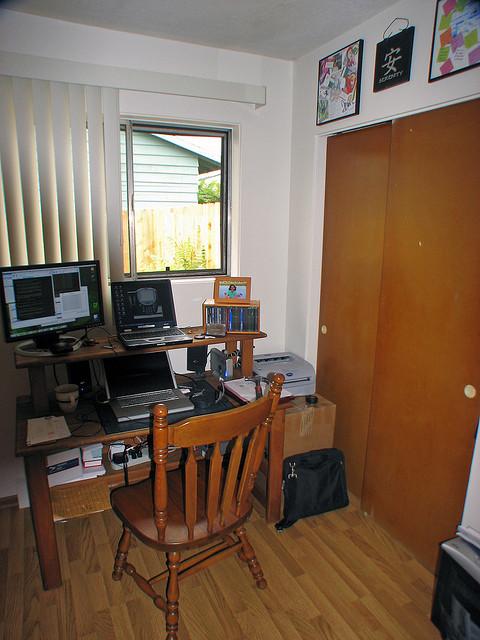What color is the chair closest to the camera?
Concise answer only. Brown. Are they moving?
Give a very brief answer. No. How many boxes are there?
Concise answer only. 1. How many computers are there?
Answer briefly. 3. What many appliances to do you see?
Answer briefly. 0. What type of room is in the foreground?
Give a very brief answer. Office. Where is the chair?
Quick response, please. At desk. What is the brand of computer?
Write a very short answer. Dell. How would you describe the floor featured in the picture?
Keep it brief. Wood. What color is that chair?
Keep it brief. Brown. How many chairs are at the table?
Be succinct. 1. 